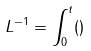<formula> <loc_0><loc_0><loc_500><loc_500>L ^ { - 1 } = \int _ { 0 } ^ { t } ( )</formula> 